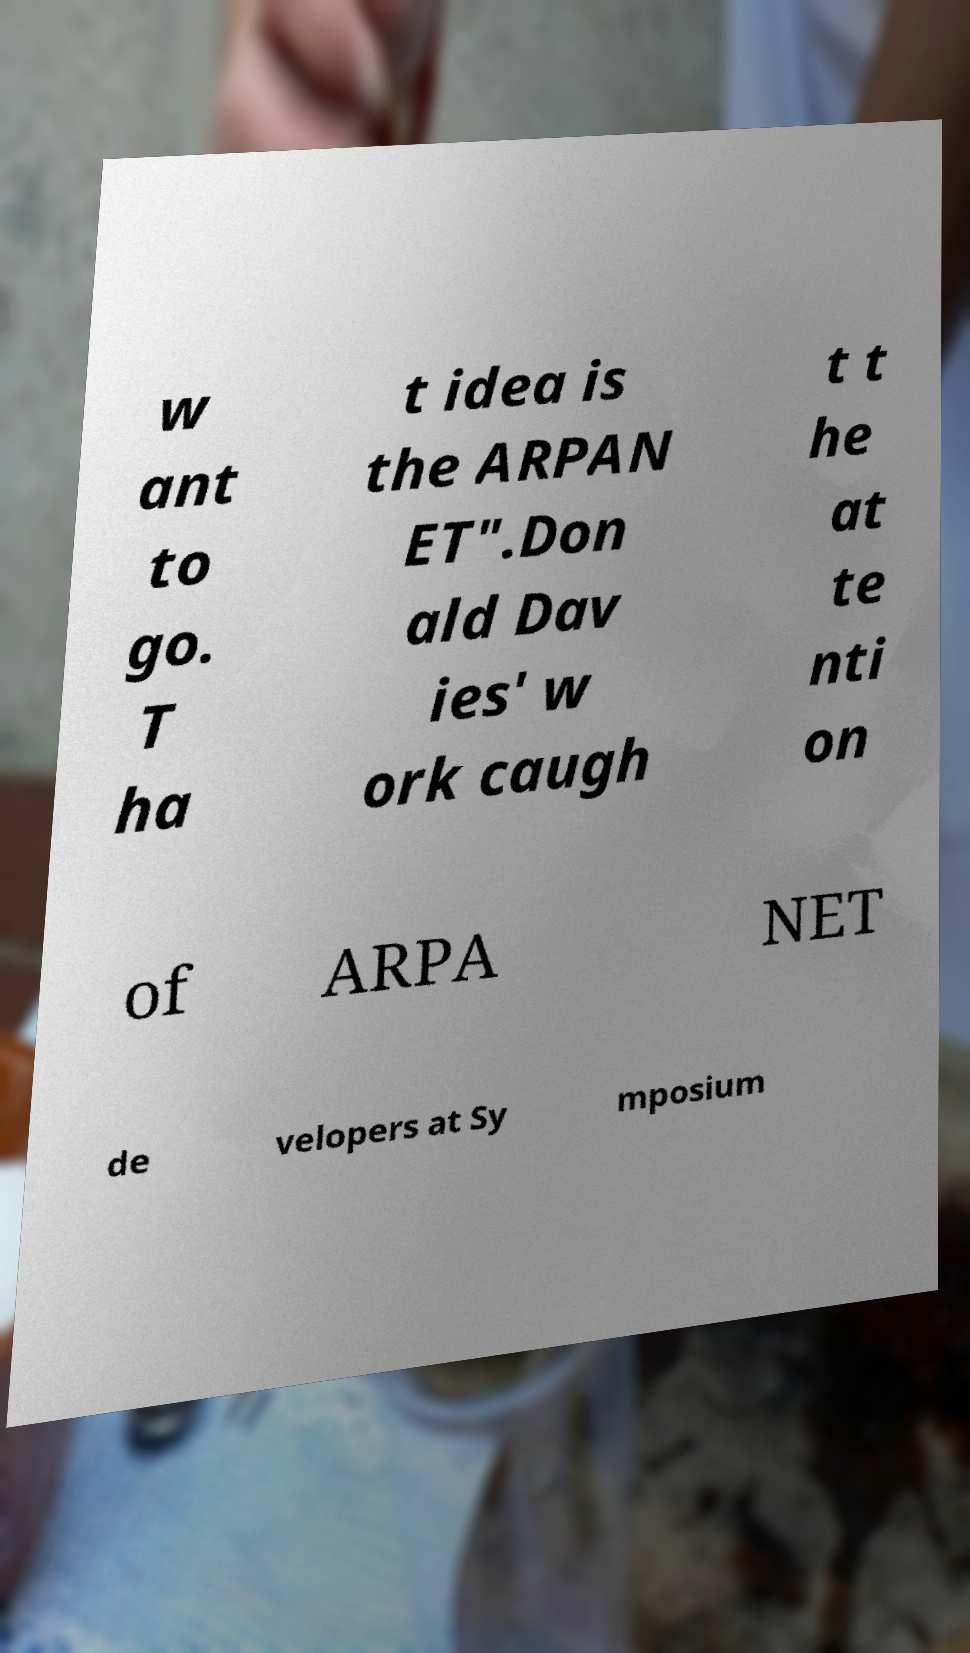What messages or text are displayed in this image? I need them in a readable, typed format. w ant to go. T ha t idea is the ARPAN ET".Don ald Dav ies' w ork caugh t t he at te nti on of ARPA NET de velopers at Sy mposium 